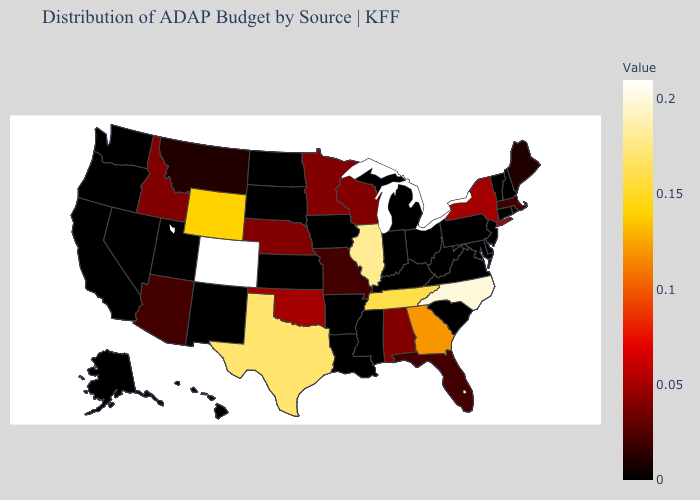Among the states that border South Carolina , which have the highest value?
Quick response, please. North Carolina. Which states have the highest value in the USA?
Short answer required. Colorado. Does Oklahoma have the lowest value in the USA?
Be succinct. No. Which states have the highest value in the USA?
Concise answer only. Colorado. Which states have the highest value in the USA?
Concise answer only. Colorado. Among the states that border Illinois , which have the lowest value?
Keep it brief. Indiana, Iowa, Kentucky. Which states have the highest value in the USA?
Quick response, please. Colorado. 